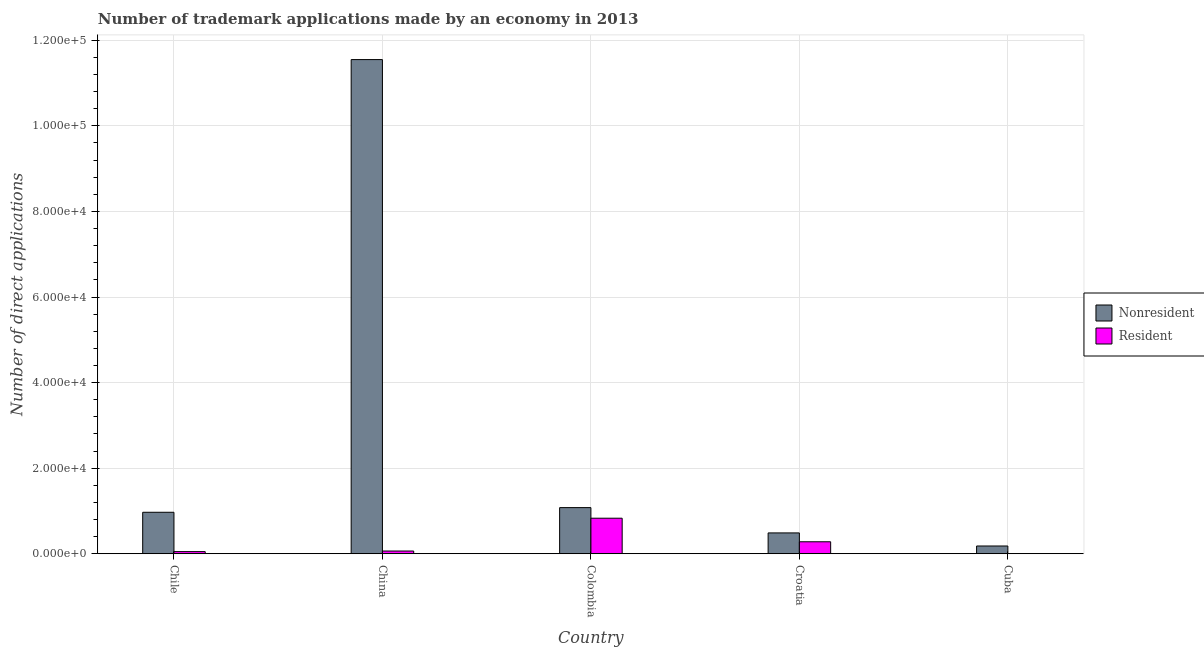Are the number of bars per tick equal to the number of legend labels?
Keep it short and to the point. Yes. What is the label of the 4th group of bars from the left?
Ensure brevity in your answer.  Croatia. In how many cases, is the number of bars for a given country not equal to the number of legend labels?
Ensure brevity in your answer.  0. What is the number of trademark applications made by residents in Cuba?
Offer a terse response. 17. Across all countries, what is the maximum number of trademark applications made by non residents?
Your response must be concise. 1.15e+05. Across all countries, what is the minimum number of trademark applications made by residents?
Provide a succinct answer. 17. In which country was the number of trademark applications made by non residents minimum?
Keep it short and to the point. Cuba. What is the total number of trademark applications made by non residents in the graph?
Ensure brevity in your answer.  1.43e+05. What is the difference between the number of trademark applications made by non residents in Chile and that in China?
Your response must be concise. -1.06e+05. What is the difference between the number of trademark applications made by residents in Croatia and the number of trademark applications made by non residents in Colombia?
Keep it short and to the point. -7983. What is the average number of trademark applications made by non residents per country?
Ensure brevity in your answer.  2.85e+04. What is the difference between the number of trademark applications made by residents and number of trademark applications made by non residents in Croatia?
Make the answer very short. -2072. What is the ratio of the number of trademark applications made by residents in Chile to that in Croatia?
Your response must be concise. 0.18. Is the number of trademark applications made by non residents in China less than that in Cuba?
Make the answer very short. No. Is the difference between the number of trademark applications made by non residents in China and Croatia greater than the difference between the number of trademark applications made by residents in China and Croatia?
Give a very brief answer. Yes. What is the difference between the highest and the second highest number of trademark applications made by residents?
Your answer should be compact. 5509. What is the difference between the highest and the lowest number of trademark applications made by non residents?
Ensure brevity in your answer.  1.14e+05. What does the 2nd bar from the left in Colombia represents?
Keep it short and to the point. Resident. What does the 2nd bar from the right in China represents?
Keep it short and to the point. Nonresident. How many bars are there?
Keep it short and to the point. 10. Are all the bars in the graph horizontal?
Your answer should be compact. No. How many countries are there in the graph?
Make the answer very short. 5. Are the values on the major ticks of Y-axis written in scientific E-notation?
Provide a succinct answer. Yes. Does the graph contain grids?
Your response must be concise. Yes. What is the title of the graph?
Provide a short and direct response. Number of trademark applications made by an economy in 2013. Does "Domestic Liabilities" appear as one of the legend labels in the graph?
Make the answer very short. No. What is the label or title of the Y-axis?
Offer a very short reply. Number of direct applications. What is the Number of direct applications in Nonresident in Chile?
Provide a short and direct response. 9688. What is the Number of direct applications of Resident in Chile?
Your response must be concise. 494. What is the Number of direct applications in Nonresident in China?
Provide a succinct answer. 1.15e+05. What is the Number of direct applications in Resident in China?
Make the answer very short. 633. What is the Number of direct applications of Nonresident in Colombia?
Offer a terse response. 1.08e+04. What is the Number of direct applications of Resident in Colombia?
Make the answer very short. 8302. What is the Number of direct applications in Nonresident in Croatia?
Offer a terse response. 4865. What is the Number of direct applications of Resident in Croatia?
Give a very brief answer. 2793. What is the Number of direct applications in Nonresident in Cuba?
Ensure brevity in your answer.  1807. Across all countries, what is the maximum Number of direct applications in Nonresident?
Provide a short and direct response. 1.15e+05. Across all countries, what is the maximum Number of direct applications of Resident?
Make the answer very short. 8302. Across all countries, what is the minimum Number of direct applications in Nonresident?
Provide a short and direct response. 1807. Across all countries, what is the minimum Number of direct applications of Resident?
Keep it short and to the point. 17. What is the total Number of direct applications in Nonresident in the graph?
Make the answer very short. 1.43e+05. What is the total Number of direct applications of Resident in the graph?
Offer a terse response. 1.22e+04. What is the difference between the Number of direct applications of Nonresident in Chile and that in China?
Your answer should be compact. -1.06e+05. What is the difference between the Number of direct applications of Resident in Chile and that in China?
Offer a very short reply. -139. What is the difference between the Number of direct applications in Nonresident in Chile and that in Colombia?
Keep it short and to the point. -1088. What is the difference between the Number of direct applications in Resident in Chile and that in Colombia?
Make the answer very short. -7808. What is the difference between the Number of direct applications in Nonresident in Chile and that in Croatia?
Offer a very short reply. 4823. What is the difference between the Number of direct applications of Resident in Chile and that in Croatia?
Offer a very short reply. -2299. What is the difference between the Number of direct applications in Nonresident in Chile and that in Cuba?
Offer a terse response. 7881. What is the difference between the Number of direct applications in Resident in Chile and that in Cuba?
Offer a terse response. 477. What is the difference between the Number of direct applications of Nonresident in China and that in Colombia?
Ensure brevity in your answer.  1.05e+05. What is the difference between the Number of direct applications of Resident in China and that in Colombia?
Offer a very short reply. -7669. What is the difference between the Number of direct applications of Nonresident in China and that in Croatia?
Your response must be concise. 1.11e+05. What is the difference between the Number of direct applications in Resident in China and that in Croatia?
Provide a succinct answer. -2160. What is the difference between the Number of direct applications in Nonresident in China and that in Cuba?
Make the answer very short. 1.14e+05. What is the difference between the Number of direct applications of Resident in China and that in Cuba?
Give a very brief answer. 616. What is the difference between the Number of direct applications of Nonresident in Colombia and that in Croatia?
Your answer should be compact. 5911. What is the difference between the Number of direct applications of Resident in Colombia and that in Croatia?
Make the answer very short. 5509. What is the difference between the Number of direct applications of Nonresident in Colombia and that in Cuba?
Your response must be concise. 8969. What is the difference between the Number of direct applications in Resident in Colombia and that in Cuba?
Offer a terse response. 8285. What is the difference between the Number of direct applications in Nonresident in Croatia and that in Cuba?
Keep it short and to the point. 3058. What is the difference between the Number of direct applications in Resident in Croatia and that in Cuba?
Provide a succinct answer. 2776. What is the difference between the Number of direct applications of Nonresident in Chile and the Number of direct applications of Resident in China?
Make the answer very short. 9055. What is the difference between the Number of direct applications in Nonresident in Chile and the Number of direct applications in Resident in Colombia?
Your answer should be compact. 1386. What is the difference between the Number of direct applications of Nonresident in Chile and the Number of direct applications of Resident in Croatia?
Your response must be concise. 6895. What is the difference between the Number of direct applications of Nonresident in Chile and the Number of direct applications of Resident in Cuba?
Offer a terse response. 9671. What is the difference between the Number of direct applications in Nonresident in China and the Number of direct applications in Resident in Colombia?
Ensure brevity in your answer.  1.07e+05. What is the difference between the Number of direct applications of Nonresident in China and the Number of direct applications of Resident in Croatia?
Offer a very short reply. 1.13e+05. What is the difference between the Number of direct applications in Nonresident in China and the Number of direct applications in Resident in Cuba?
Your answer should be very brief. 1.15e+05. What is the difference between the Number of direct applications in Nonresident in Colombia and the Number of direct applications in Resident in Croatia?
Give a very brief answer. 7983. What is the difference between the Number of direct applications in Nonresident in Colombia and the Number of direct applications in Resident in Cuba?
Ensure brevity in your answer.  1.08e+04. What is the difference between the Number of direct applications of Nonresident in Croatia and the Number of direct applications of Resident in Cuba?
Keep it short and to the point. 4848. What is the average Number of direct applications of Nonresident per country?
Your answer should be compact. 2.85e+04. What is the average Number of direct applications in Resident per country?
Ensure brevity in your answer.  2447.8. What is the difference between the Number of direct applications of Nonresident and Number of direct applications of Resident in Chile?
Give a very brief answer. 9194. What is the difference between the Number of direct applications in Nonresident and Number of direct applications in Resident in China?
Keep it short and to the point. 1.15e+05. What is the difference between the Number of direct applications of Nonresident and Number of direct applications of Resident in Colombia?
Offer a terse response. 2474. What is the difference between the Number of direct applications of Nonresident and Number of direct applications of Resident in Croatia?
Give a very brief answer. 2072. What is the difference between the Number of direct applications in Nonresident and Number of direct applications in Resident in Cuba?
Make the answer very short. 1790. What is the ratio of the Number of direct applications in Nonresident in Chile to that in China?
Offer a terse response. 0.08. What is the ratio of the Number of direct applications in Resident in Chile to that in China?
Ensure brevity in your answer.  0.78. What is the ratio of the Number of direct applications of Nonresident in Chile to that in Colombia?
Keep it short and to the point. 0.9. What is the ratio of the Number of direct applications in Resident in Chile to that in Colombia?
Ensure brevity in your answer.  0.06. What is the ratio of the Number of direct applications of Nonresident in Chile to that in Croatia?
Keep it short and to the point. 1.99. What is the ratio of the Number of direct applications in Resident in Chile to that in Croatia?
Your answer should be compact. 0.18. What is the ratio of the Number of direct applications in Nonresident in Chile to that in Cuba?
Keep it short and to the point. 5.36. What is the ratio of the Number of direct applications of Resident in Chile to that in Cuba?
Provide a short and direct response. 29.06. What is the ratio of the Number of direct applications of Nonresident in China to that in Colombia?
Give a very brief answer. 10.72. What is the ratio of the Number of direct applications in Resident in China to that in Colombia?
Your response must be concise. 0.08. What is the ratio of the Number of direct applications of Nonresident in China to that in Croatia?
Ensure brevity in your answer.  23.74. What is the ratio of the Number of direct applications in Resident in China to that in Croatia?
Your answer should be very brief. 0.23. What is the ratio of the Number of direct applications in Nonresident in China to that in Cuba?
Provide a succinct answer. 63.91. What is the ratio of the Number of direct applications in Resident in China to that in Cuba?
Keep it short and to the point. 37.24. What is the ratio of the Number of direct applications of Nonresident in Colombia to that in Croatia?
Offer a terse response. 2.21. What is the ratio of the Number of direct applications of Resident in Colombia to that in Croatia?
Offer a terse response. 2.97. What is the ratio of the Number of direct applications in Nonresident in Colombia to that in Cuba?
Offer a terse response. 5.96. What is the ratio of the Number of direct applications of Resident in Colombia to that in Cuba?
Make the answer very short. 488.35. What is the ratio of the Number of direct applications of Nonresident in Croatia to that in Cuba?
Provide a short and direct response. 2.69. What is the ratio of the Number of direct applications of Resident in Croatia to that in Cuba?
Provide a succinct answer. 164.29. What is the difference between the highest and the second highest Number of direct applications of Nonresident?
Keep it short and to the point. 1.05e+05. What is the difference between the highest and the second highest Number of direct applications of Resident?
Your response must be concise. 5509. What is the difference between the highest and the lowest Number of direct applications in Nonresident?
Offer a very short reply. 1.14e+05. What is the difference between the highest and the lowest Number of direct applications of Resident?
Your answer should be compact. 8285. 